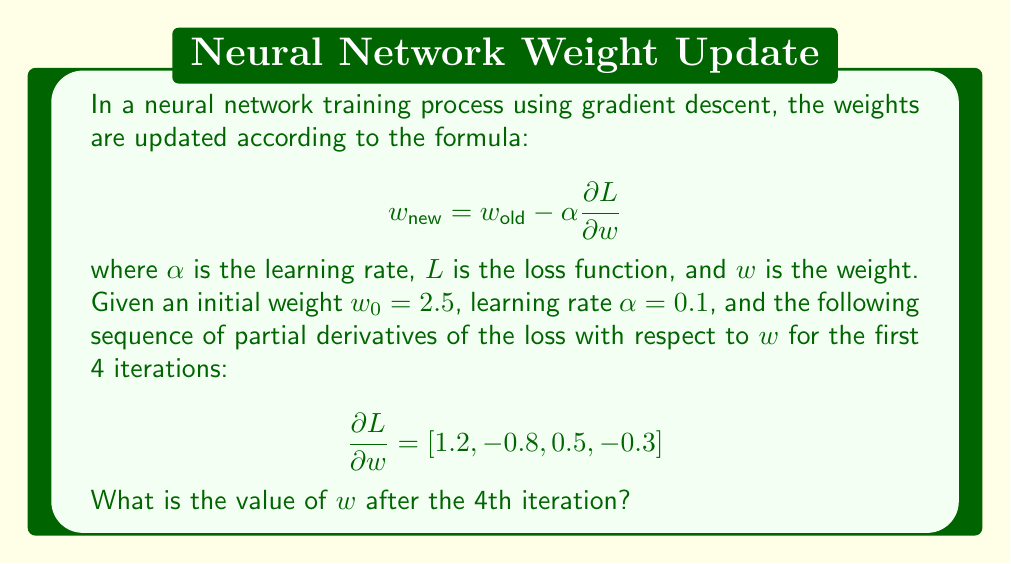Can you solve this math problem? Let's calculate the weight updates step by step:

1. Initial weight: $w_0 = 2.5$

2. First iteration:
   $w_1 = w_0 - \alpha \frac{\partial L}{\partial w}$
   $w_1 = 2.5 - 0.1 \times 1.2 = 2.5 - 0.12 = 2.38$

3. Second iteration:
   $w_2 = w_1 - \alpha \frac{\partial L}{\partial w}$
   $w_2 = 2.38 - 0.1 \times (-0.8) = 2.38 + 0.08 = 2.46$

4. Third iteration:
   $w_3 = w_2 - \alpha \frac{\partial L}{\partial w}$
   $w_3 = 2.46 - 0.1 \times 0.5 = 2.46 - 0.05 = 2.41$

5. Fourth iteration:
   $w_4 = w_3 - \alpha \frac{\partial L}{\partial w}$
   $w_4 = 2.41 - 0.1 \times (-0.3) = 2.41 + 0.03 = 2.44$

Therefore, after the 4th iteration, the value of $w$ is 2.44.
Answer: 2.44 